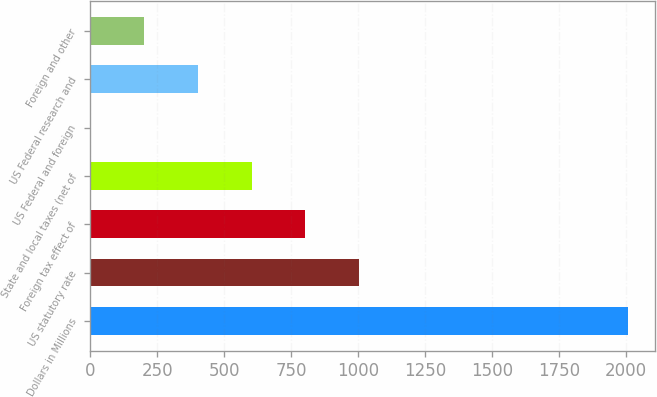Convert chart. <chart><loc_0><loc_0><loc_500><loc_500><bar_chart><fcel>Dollars in Millions<fcel>US statutory rate<fcel>Foreign tax effect of<fcel>State and local taxes (net of<fcel>US Federal and foreign<fcel>US Federal research and<fcel>Foreign and other<nl><fcel>2008<fcel>1004.35<fcel>803.62<fcel>602.89<fcel>0.7<fcel>402.16<fcel>201.43<nl></chart> 